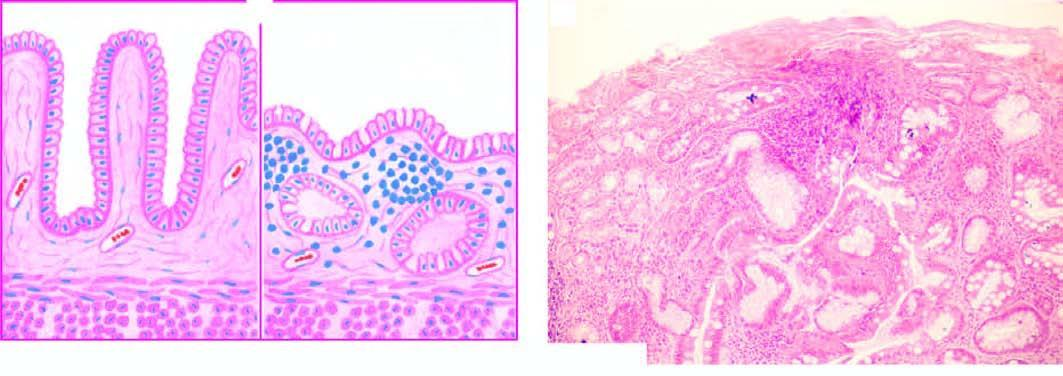what is there marked with disappearance of gastric glands and appearance of goblet cells intestinal metaplasia?
Answer the question using a single word or phrase. Atrophy (intestinal metaplasia) 